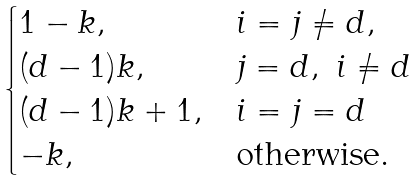Convert formula to latex. <formula><loc_0><loc_0><loc_500><loc_500>\begin{cases} 1 - k , & i = j \not = d , \\ ( d - 1 ) k , & j = d , \ i \not = d \\ ( d - 1 ) k + 1 , & i = j = d \\ - k , & \text {otherwise} . \end{cases}</formula> 